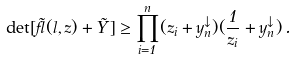<formula> <loc_0><loc_0><loc_500><loc_500>\det [ \tilde { \gamma } ( { l } , { z } ) + \tilde { Y } ] \geq \prod _ { i = 1 } ^ { n } ( z _ { i } + { y } _ { n } ^ { \downarrow } ) ( \frac { 1 } { z _ { i } } + { y } ^ { \downarrow } _ { n } ) \, .</formula> 